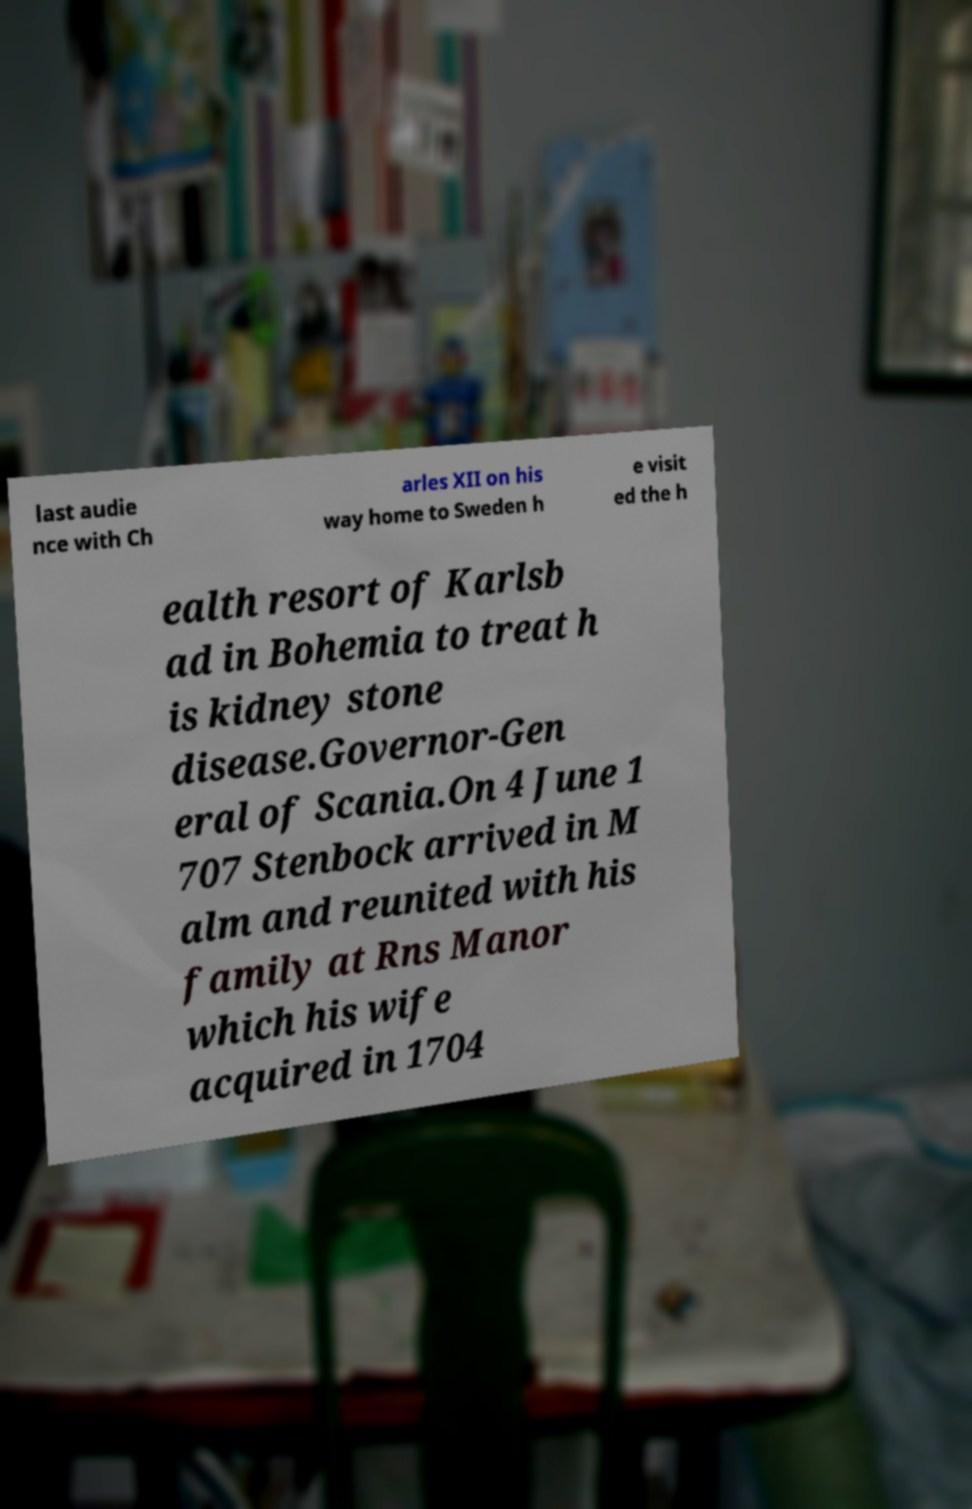There's text embedded in this image that I need extracted. Can you transcribe it verbatim? last audie nce with Ch arles XII on his way home to Sweden h e visit ed the h ealth resort of Karlsb ad in Bohemia to treat h is kidney stone disease.Governor-Gen eral of Scania.On 4 June 1 707 Stenbock arrived in M alm and reunited with his family at Rns Manor which his wife acquired in 1704 